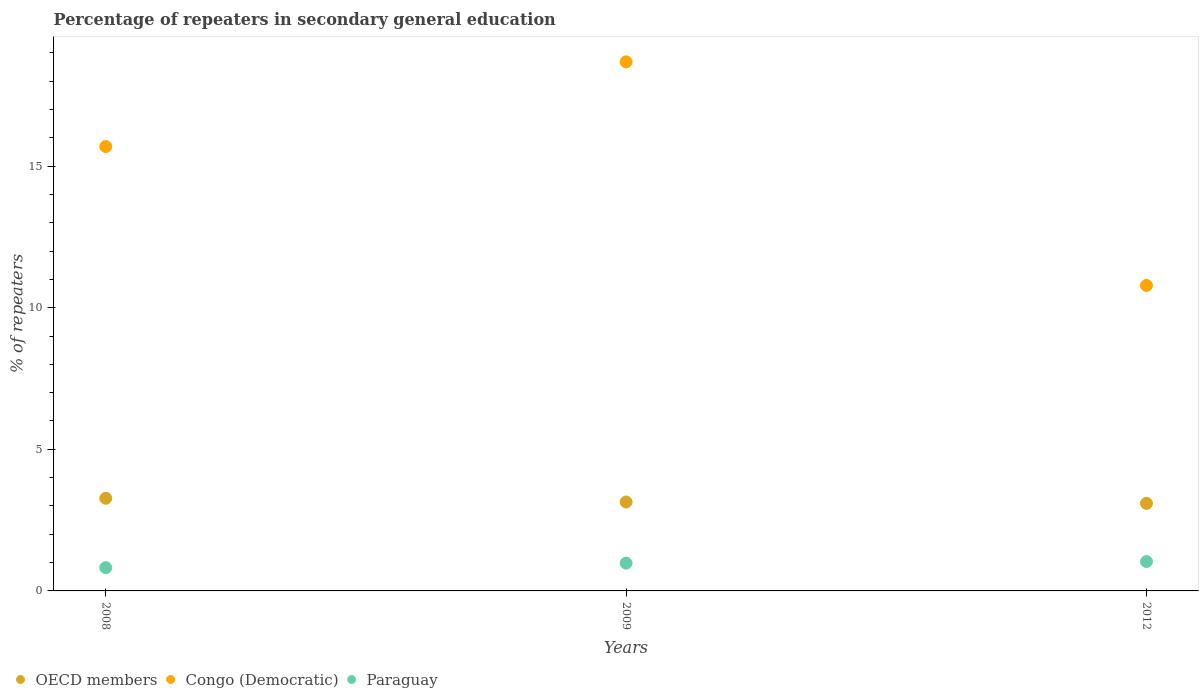How many different coloured dotlines are there?
Ensure brevity in your answer.  3. Is the number of dotlines equal to the number of legend labels?
Your response must be concise. Yes. What is the percentage of repeaters in secondary general education in Congo (Democratic) in 2008?
Ensure brevity in your answer.  15.69. Across all years, what is the maximum percentage of repeaters in secondary general education in Paraguay?
Your response must be concise. 1.04. Across all years, what is the minimum percentage of repeaters in secondary general education in Paraguay?
Offer a very short reply. 0.82. In which year was the percentage of repeaters in secondary general education in OECD members maximum?
Give a very brief answer. 2008. In which year was the percentage of repeaters in secondary general education in Paraguay minimum?
Your response must be concise. 2008. What is the total percentage of repeaters in secondary general education in Congo (Democratic) in the graph?
Provide a succinct answer. 45.16. What is the difference between the percentage of repeaters in secondary general education in Paraguay in 2008 and that in 2012?
Make the answer very short. -0.22. What is the difference between the percentage of repeaters in secondary general education in Congo (Democratic) in 2008 and the percentage of repeaters in secondary general education in OECD members in 2012?
Keep it short and to the point. 12.6. What is the average percentage of repeaters in secondary general education in OECD members per year?
Your response must be concise. 3.17. In the year 2008, what is the difference between the percentage of repeaters in secondary general education in Congo (Democratic) and percentage of repeaters in secondary general education in OECD members?
Provide a short and direct response. 12.42. What is the ratio of the percentage of repeaters in secondary general education in Paraguay in 2009 to that in 2012?
Make the answer very short. 0.95. Is the percentage of repeaters in secondary general education in OECD members in 2008 less than that in 2012?
Offer a very short reply. No. What is the difference between the highest and the second highest percentage of repeaters in secondary general education in Paraguay?
Offer a terse response. 0.06. What is the difference between the highest and the lowest percentage of repeaters in secondary general education in Paraguay?
Provide a short and direct response. 0.22. In how many years, is the percentage of repeaters in secondary general education in OECD members greater than the average percentage of repeaters in secondary general education in OECD members taken over all years?
Make the answer very short. 1. Is the sum of the percentage of repeaters in secondary general education in Paraguay in 2008 and 2012 greater than the maximum percentage of repeaters in secondary general education in OECD members across all years?
Your answer should be very brief. No. Is it the case that in every year, the sum of the percentage of repeaters in secondary general education in OECD members and percentage of repeaters in secondary general education in Congo (Democratic)  is greater than the percentage of repeaters in secondary general education in Paraguay?
Offer a terse response. Yes. How many dotlines are there?
Your answer should be compact. 3. Does the graph contain any zero values?
Your response must be concise. No. Does the graph contain grids?
Your answer should be compact. No. Where does the legend appear in the graph?
Make the answer very short. Bottom left. What is the title of the graph?
Keep it short and to the point. Percentage of repeaters in secondary general education. Does "Monaco" appear as one of the legend labels in the graph?
Your response must be concise. No. What is the label or title of the X-axis?
Your response must be concise. Years. What is the label or title of the Y-axis?
Provide a succinct answer. % of repeaters. What is the % of repeaters of OECD members in 2008?
Offer a very short reply. 3.27. What is the % of repeaters in Congo (Democratic) in 2008?
Keep it short and to the point. 15.69. What is the % of repeaters in Paraguay in 2008?
Your response must be concise. 0.82. What is the % of repeaters in OECD members in 2009?
Your answer should be compact. 3.14. What is the % of repeaters in Congo (Democratic) in 2009?
Make the answer very short. 18.68. What is the % of repeaters of Paraguay in 2009?
Offer a terse response. 0.98. What is the % of repeaters in OECD members in 2012?
Your answer should be very brief. 3.09. What is the % of repeaters in Congo (Democratic) in 2012?
Your answer should be very brief. 10.79. What is the % of repeaters of Paraguay in 2012?
Provide a short and direct response. 1.04. Across all years, what is the maximum % of repeaters in OECD members?
Provide a short and direct response. 3.27. Across all years, what is the maximum % of repeaters of Congo (Democratic)?
Offer a terse response. 18.68. Across all years, what is the maximum % of repeaters in Paraguay?
Offer a terse response. 1.04. Across all years, what is the minimum % of repeaters in OECD members?
Your answer should be very brief. 3.09. Across all years, what is the minimum % of repeaters of Congo (Democratic)?
Keep it short and to the point. 10.79. Across all years, what is the minimum % of repeaters in Paraguay?
Provide a succinct answer. 0.82. What is the total % of repeaters of OECD members in the graph?
Provide a succinct answer. 9.5. What is the total % of repeaters of Congo (Democratic) in the graph?
Offer a terse response. 45.16. What is the total % of repeaters in Paraguay in the graph?
Ensure brevity in your answer.  2.84. What is the difference between the % of repeaters of OECD members in 2008 and that in 2009?
Ensure brevity in your answer.  0.13. What is the difference between the % of repeaters in Congo (Democratic) in 2008 and that in 2009?
Offer a terse response. -2.99. What is the difference between the % of repeaters of Paraguay in 2008 and that in 2009?
Keep it short and to the point. -0.16. What is the difference between the % of repeaters of OECD members in 2008 and that in 2012?
Your answer should be very brief. 0.18. What is the difference between the % of repeaters in Congo (Democratic) in 2008 and that in 2012?
Your answer should be very brief. 4.9. What is the difference between the % of repeaters of Paraguay in 2008 and that in 2012?
Your answer should be very brief. -0.22. What is the difference between the % of repeaters in OECD members in 2009 and that in 2012?
Offer a terse response. 0.05. What is the difference between the % of repeaters of Congo (Democratic) in 2009 and that in 2012?
Keep it short and to the point. 7.9. What is the difference between the % of repeaters in Paraguay in 2009 and that in 2012?
Your answer should be compact. -0.06. What is the difference between the % of repeaters in OECD members in 2008 and the % of repeaters in Congo (Democratic) in 2009?
Provide a short and direct response. -15.41. What is the difference between the % of repeaters in OECD members in 2008 and the % of repeaters in Paraguay in 2009?
Your answer should be compact. 2.29. What is the difference between the % of repeaters of Congo (Democratic) in 2008 and the % of repeaters of Paraguay in 2009?
Give a very brief answer. 14.71. What is the difference between the % of repeaters of OECD members in 2008 and the % of repeaters of Congo (Democratic) in 2012?
Keep it short and to the point. -7.51. What is the difference between the % of repeaters in OECD members in 2008 and the % of repeaters in Paraguay in 2012?
Ensure brevity in your answer.  2.23. What is the difference between the % of repeaters of Congo (Democratic) in 2008 and the % of repeaters of Paraguay in 2012?
Your answer should be very brief. 14.65. What is the difference between the % of repeaters of OECD members in 2009 and the % of repeaters of Congo (Democratic) in 2012?
Offer a terse response. -7.65. What is the difference between the % of repeaters in OECD members in 2009 and the % of repeaters in Paraguay in 2012?
Your response must be concise. 2.1. What is the difference between the % of repeaters in Congo (Democratic) in 2009 and the % of repeaters in Paraguay in 2012?
Offer a terse response. 17.64. What is the average % of repeaters of OECD members per year?
Offer a very short reply. 3.17. What is the average % of repeaters of Congo (Democratic) per year?
Provide a succinct answer. 15.05. What is the average % of repeaters of Paraguay per year?
Provide a succinct answer. 0.95. In the year 2008, what is the difference between the % of repeaters in OECD members and % of repeaters in Congo (Democratic)?
Offer a terse response. -12.42. In the year 2008, what is the difference between the % of repeaters of OECD members and % of repeaters of Paraguay?
Ensure brevity in your answer.  2.45. In the year 2008, what is the difference between the % of repeaters in Congo (Democratic) and % of repeaters in Paraguay?
Provide a short and direct response. 14.87. In the year 2009, what is the difference between the % of repeaters in OECD members and % of repeaters in Congo (Democratic)?
Your response must be concise. -15.54. In the year 2009, what is the difference between the % of repeaters in OECD members and % of repeaters in Paraguay?
Provide a short and direct response. 2.16. In the year 2009, what is the difference between the % of repeaters of Congo (Democratic) and % of repeaters of Paraguay?
Give a very brief answer. 17.7. In the year 2012, what is the difference between the % of repeaters of OECD members and % of repeaters of Congo (Democratic)?
Make the answer very short. -7.69. In the year 2012, what is the difference between the % of repeaters in OECD members and % of repeaters in Paraguay?
Make the answer very short. 2.05. In the year 2012, what is the difference between the % of repeaters in Congo (Democratic) and % of repeaters in Paraguay?
Offer a very short reply. 9.75. What is the ratio of the % of repeaters of OECD members in 2008 to that in 2009?
Your answer should be compact. 1.04. What is the ratio of the % of repeaters of Congo (Democratic) in 2008 to that in 2009?
Ensure brevity in your answer.  0.84. What is the ratio of the % of repeaters of Paraguay in 2008 to that in 2009?
Your response must be concise. 0.84. What is the ratio of the % of repeaters of OECD members in 2008 to that in 2012?
Ensure brevity in your answer.  1.06. What is the ratio of the % of repeaters in Congo (Democratic) in 2008 to that in 2012?
Keep it short and to the point. 1.45. What is the ratio of the % of repeaters in Paraguay in 2008 to that in 2012?
Your answer should be compact. 0.79. What is the ratio of the % of repeaters of OECD members in 2009 to that in 2012?
Your answer should be compact. 1.02. What is the ratio of the % of repeaters of Congo (Democratic) in 2009 to that in 2012?
Make the answer very short. 1.73. What is the ratio of the % of repeaters of Paraguay in 2009 to that in 2012?
Provide a succinct answer. 0.95. What is the difference between the highest and the second highest % of repeaters in OECD members?
Your answer should be compact. 0.13. What is the difference between the highest and the second highest % of repeaters of Congo (Democratic)?
Provide a short and direct response. 2.99. What is the difference between the highest and the second highest % of repeaters of Paraguay?
Give a very brief answer. 0.06. What is the difference between the highest and the lowest % of repeaters of OECD members?
Make the answer very short. 0.18. What is the difference between the highest and the lowest % of repeaters in Congo (Democratic)?
Keep it short and to the point. 7.9. What is the difference between the highest and the lowest % of repeaters in Paraguay?
Your answer should be compact. 0.22. 